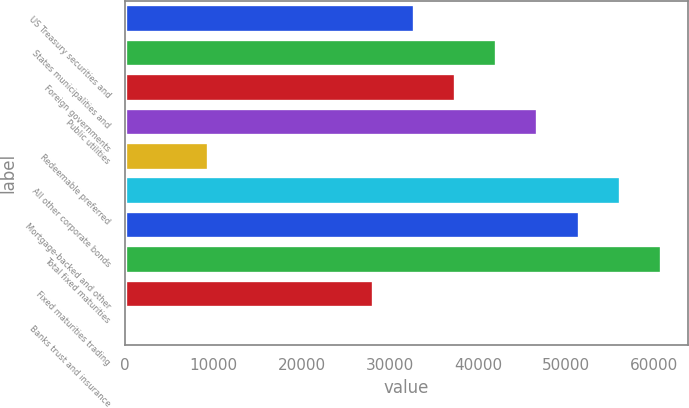Convert chart. <chart><loc_0><loc_0><loc_500><loc_500><bar_chart><fcel>US Treasury securities and<fcel>States municipalities and<fcel>Foreign governments<fcel>Public utilities<fcel>Redeemable preferred<fcel>All other corporate bonds<fcel>Mortgage-backed and other<fcel>Total fixed maturities<fcel>Fixed maturities trading<fcel>Banks trust and insurance<nl><fcel>32718.8<fcel>42065.5<fcel>37392.2<fcel>46738.9<fcel>9352.02<fcel>56085.6<fcel>51412.3<fcel>60759<fcel>28045.5<fcel>5.3<nl></chart> 